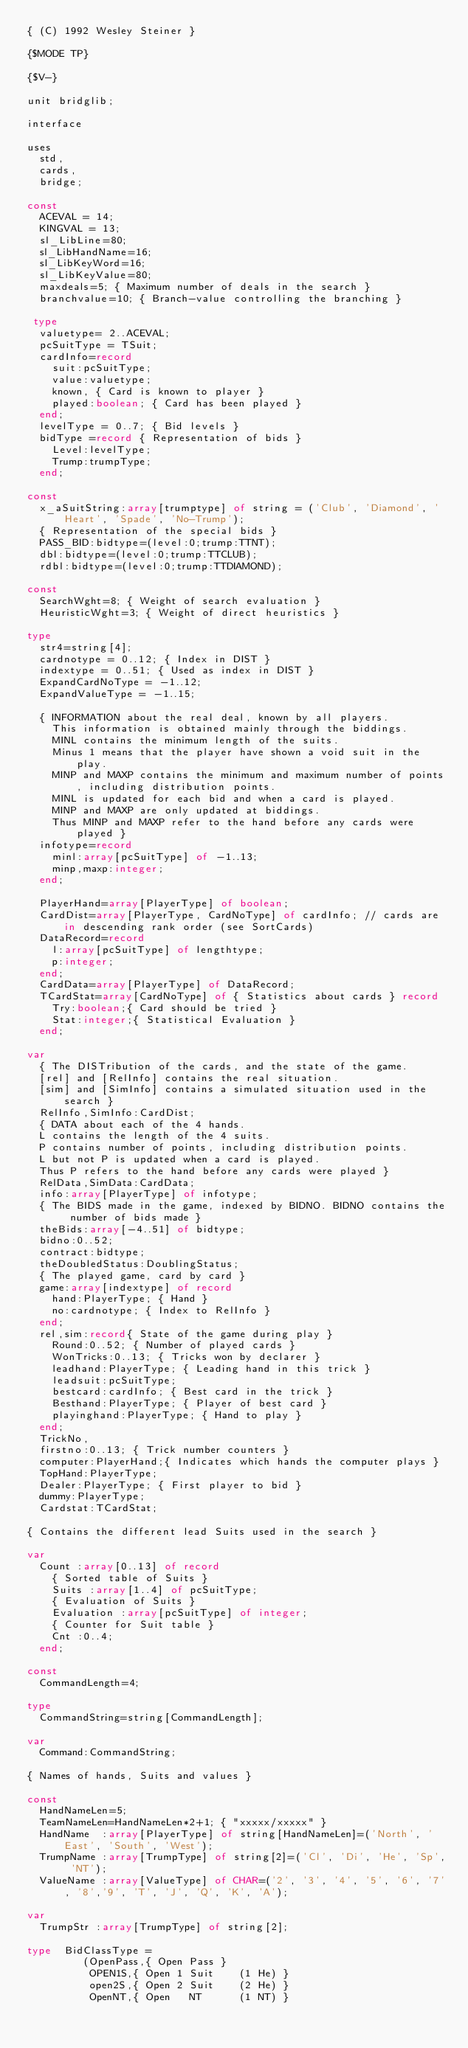Convert code to text. <code><loc_0><loc_0><loc_500><loc_500><_Pascal_>{ (C) 1992 Wesley Steiner }

{$MODE TP}

{$V-}

unit bridglib;

interface

uses
	std,
	cards,
	bridge;

const
	ACEVAL = 14;
	KINGVAL = 13;
	sl_LibLine=80;
	sl_LibHandName=16;
	sl_LibKeyWord=16;
	sl_LibKeyValue=80;
	maxdeals=5; { Maximum number of deals in the search }
	branchvalue=10; { Branch-value controlling the branching }

 type
	valuetype= 2..ACEVAL;
	pcSuitType = TSuit;
	cardInfo=record
		suit:pcSuitType;
		value:valuetype;
		known, { Card is known to player }
		played:boolean; { Card has been played }
	end;
	levelType = 0..7; { Bid levels }
	bidType =record { Representation of bids }
		Level:levelType;
		Trump:trumpType;
	end;

const
	x_aSuitString:array[trumptype] of string = ('Club', 'Diamond', 'Heart', 'Spade', 'No-Trump');
	{ Representation of the special bids }
	PASS_BID:bidtype=(level:0;trump:TTNT);
	dbl:bidtype=(level:0;trump:TTCLUB);
	rdbl:bidtype=(level:0;trump:TTDIAMOND);

const
	SearchWght=8; { Weight of search evaluation }
	HeuristicWght=3; { Weight of direct heuristics }

type
	str4=string[4];
	cardnotype = 0..12; { Index in DIST }
	indextype = 0..51; { Used as index in DIST }
	ExpandCardNoType = -1..12;
	ExpandValueType = -1..15;

	{ INFORMATION about the real deal, known by all players.
		This information is obtained mainly through the biddings.
		MINL contains the minimum length of the suits.
		Minus 1 means that the player have shown a void suit in the play.
		MINP and MAXP contains the minimum and maximum number of points, including distribution points.
		MINL is updated for each bid and when a card is played.
		MINP and MAXP are only updated at biddings.
		Thus MINP and MAXP refer to the hand before any cards were played }
	infotype=record
		minl:array[pcSuitType] of -1..13;
		minp,maxp:integer;
	end;

	PlayerHand=array[PlayerType] of boolean;
	CardDist=array[PlayerType, CardNoType] of cardInfo; // cards are in descending rank order (see SortCards)
	DataRecord=record
		l:array[pcSuitType] of lengthtype;
		p:integer;
	end;
	CardData=array[PlayerType] of DataRecord;
	TCardStat=array[CardNoType] of { Statistics about cards } record
		Try:boolean;{ Card should be tried }
		Stat:integer;{ Statistical Evaluation }
	end;

var
	{ The DISTribution of the cards, and the state of the game.
	[rel] and [RelInfo] contains the real situation.
	[sim] and [SimInfo] contains a simulated situation used in the search }
	RelInfo,SimInfo:CardDist;
	{ DATA about each of the 4 hands.
	L contains the length of the 4 suits.
	P contains number of points, including distribution points.
	L but not P is updated when a card is played.
	Thus P refers to the hand before any cards were played }
	RelData,SimData:CardData;
	info:array[PlayerType] of infotype;
	{ The BIDS made in the game, indexed by BIDNO. BIDNO contains the number of bids made }
	theBids:array[-4..51] of bidtype;
	bidno:0..52;
	contract:bidtype;
	theDoubledStatus:DoublingStatus;
	{ The played game, card by card }
	game:array[indextype] of record
		hand:PlayerType; { Hand }
		no:cardnotype; { Index to RelInfo }
	end;
	rel,sim:record{ State of the game during play }
		Round:0..52; { Number of played cards }
		WonTricks:0..13; { Tricks won by declarer }
		leadhand:PlayerType; { Leading hand in this trick }
		leadsuit:pcSuitType;
		bestcard:cardInfo; { Best card in the trick }
		Besthand:PlayerType; { Player of best card }
		playinghand:PlayerType; { Hand to play }
	end;
	TrickNo,
	firstno:0..13; { Trick number counters }
	computer:PlayerHand;{ Indicates which hands the computer plays }
	TopHand:PlayerType;
	Dealer:PlayerType; { First player to bid }
	dummy:PlayerType;
	Cardstat:TCardStat;

{ Contains the different lead Suits used in the search }

var
	Count :array[0..13] of record
		{ Sorted table of Suits }
		Suits :array[1..4] of pcSuitType;
		{ Evaluation of Suits }
		Evaluation :array[pcSuitType] of integer;
		{ Counter for Suit table }
		Cnt :0..4;
	end;

const
	CommandLength=4;

type
	CommandString=string[CommandLength];

var
	Command:CommandString;

{ Names of hands, Suits and values }

const
	HandNameLen=5;
	TeamNameLen=HandNameLen*2+1; { "xxxxx/xxxxx" }
	HandName  :array[PlayerType] of string[HandNameLen]=('North', 'East', 'South', 'West');
	TrumpName :array[TrumpType] of string[2]=('Cl', 'Di', 'He', 'Sp', 'NT');
	ValueName :array[ValueType] of CHAR=('2', '3', '4', '5', '6', '7', '8','9', 'T', 'J', 'Q', 'K', 'A');

var
	TrumpStr :array[TrumpType] of string[2];

type  BidClassType =
				 (OpenPass,{ Open Pass }
					OPEN1S,{ Open 1 Suit    (1 He) }
					open2S,{ Open 2 Suit    (2 He) }
					OpenNT,{ Open   NT      (1 NT) }</code> 